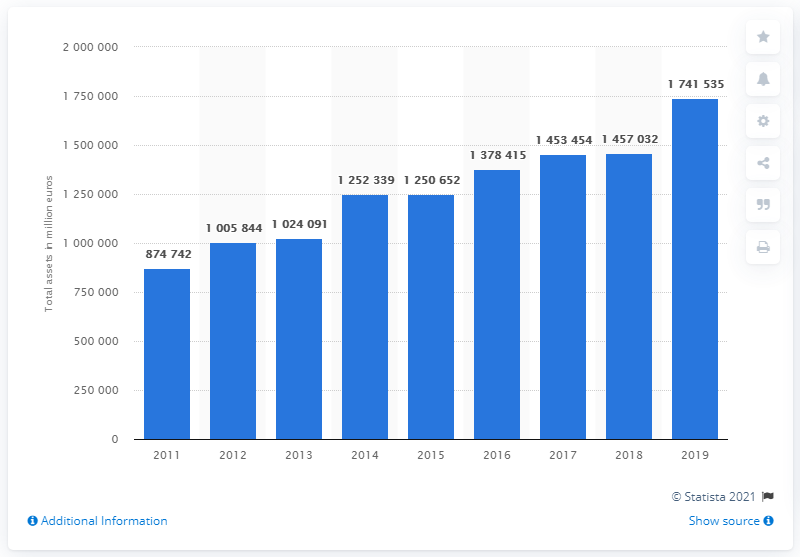Mention a couple of crucial points in this snapshot. In 2019, the value of Dutch pension funds was approximately 174,153,500. 